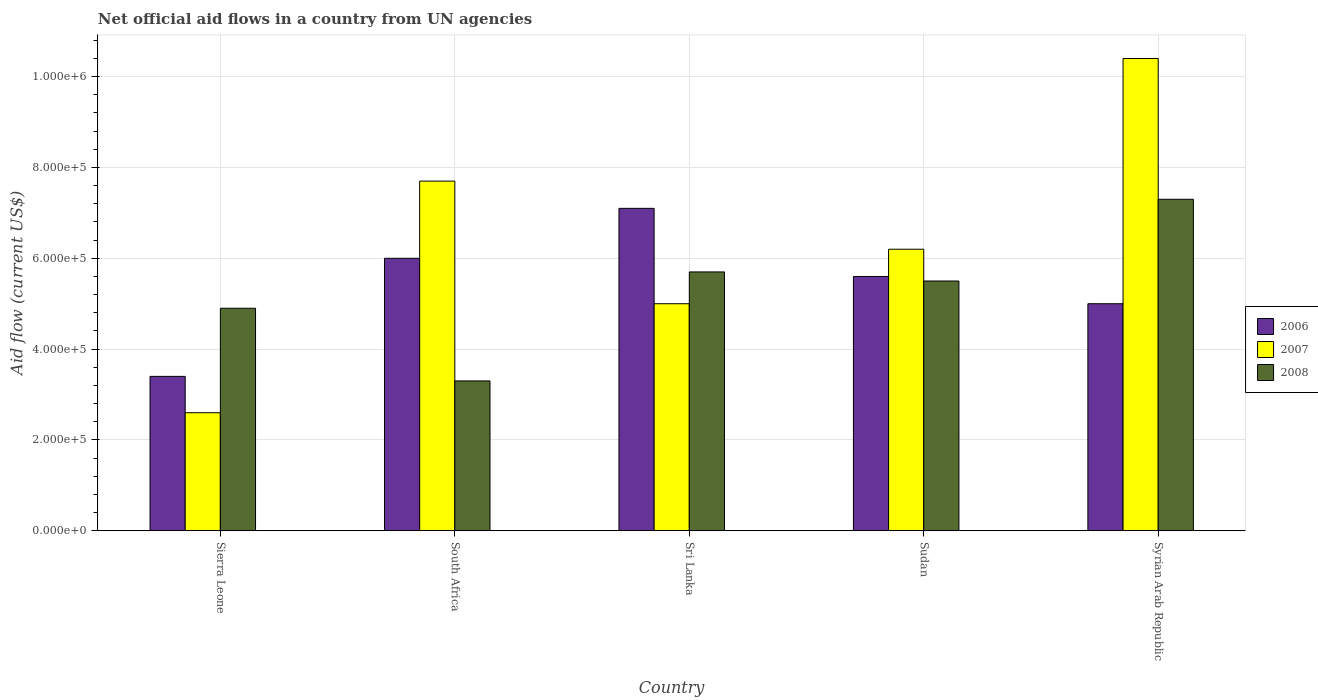How many groups of bars are there?
Keep it short and to the point. 5. How many bars are there on the 4th tick from the left?
Keep it short and to the point. 3. What is the label of the 5th group of bars from the left?
Your answer should be very brief. Syrian Arab Republic. Across all countries, what is the maximum net official aid flow in 2007?
Your answer should be very brief. 1.04e+06. Across all countries, what is the minimum net official aid flow in 2008?
Give a very brief answer. 3.30e+05. In which country was the net official aid flow in 2008 maximum?
Provide a succinct answer. Syrian Arab Republic. In which country was the net official aid flow in 2006 minimum?
Offer a terse response. Sierra Leone. What is the total net official aid flow in 2008 in the graph?
Your answer should be very brief. 2.67e+06. What is the difference between the net official aid flow in 2006 in Sri Lanka and that in Syrian Arab Republic?
Your answer should be compact. 2.10e+05. What is the difference between the net official aid flow in 2007 in Sri Lanka and the net official aid flow in 2006 in Sierra Leone?
Provide a short and direct response. 1.60e+05. What is the average net official aid flow in 2006 per country?
Provide a succinct answer. 5.42e+05. What is the difference between the net official aid flow of/in 2006 and net official aid flow of/in 2008 in Sri Lanka?
Make the answer very short. 1.40e+05. What is the ratio of the net official aid flow in 2006 in Sierra Leone to that in South Africa?
Keep it short and to the point. 0.57. What is the difference between the highest and the second highest net official aid flow in 2007?
Offer a very short reply. 4.20e+05. What is the difference between the highest and the lowest net official aid flow in 2008?
Your answer should be very brief. 4.00e+05. Is it the case that in every country, the sum of the net official aid flow in 2008 and net official aid flow in 2007 is greater than the net official aid flow in 2006?
Your answer should be very brief. Yes. How many bars are there?
Give a very brief answer. 15. Are all the bars in the graph horizontal?
Ensure brevity in your answer.  No. Are the values on the major ticks of Y-axis written in scientific E-notation?
Offer a very short reply. Yes. Does the graph contain grids?
Make the answer very short. Yes. Where does the legend appear in the graph?
Your response must be concise. Center right. How many legend labels are there?
Offer a terse response. 3. What is the title of the graph?
Give a very brief answer. Net official aid flows in a country from UN agencies. What is the label or title of the X-axis?
Your answer should be very brief. Country. What is the Aid flow (current US$) in 2006 in Sierra Leone?
Your response must be concise. 3.40e+05. What is the Aid flow (current US$) in 2007 in Sierra Leone?
Keep it short and to the point. 2.60e+05. What is the Aid flow (current US$) of 2007 in South Africa?
Provide a short and direct response. 7.70e+05. What is the Aid flow (current US$) in 2008 in South Africa?
Give a very brief answer. 3.30e+05. What is the Aid flow (current US$) of 2006 in Sri Lanka?
Keep it short and to the point. 7.10e+05. What is the Aid flow (current US$) of 2008 in Sri Lanka?
Provide a succinct answer. 5.70e+05. What is the Aid flow (current US$) in 2006 in Sudan?
Your response must be concise. 5.60e+05. What is the Aid flow (current US$) of 2007 in Sudan?
Provide a succinct answer. 6.20e+05. What is the Aid flow (current US$) in 2007 in Syrian Arab Republic?
Offer a terse response. 1.04e+06. What is the Aid flow (current US$) in 2008 in Syrian Arab Republic?
Offer a very short reply. 7.30e+05. Across all countries, what is the maximum Aid flow (current US$) in 2006?
Keep it short and to the point. 7.10e+05. Across all countries, what is the maximum Aid flow (current US$) of 2007?
Your response must be concise. 1.04e+06. Across all countries, what is the maximum Aid flow (current US$) in 2008?
Your answer should be very brief. 7.30e+05. Across all countries, what is the minimum Aid flow (current US$) of 2006?
Offer a terse response. 3.40e+05. What is the total Aid flow (current US$) in 2006 in the graph?
Provide a succinct answer. 2.71e+06. What is the total Aid flow (current US$) in 2007 in the graph?
Offer a very short reply. 3.19e+06. What is the total Aid flow (current US$) in 2008 in the graph?
Offer a very short reply. 2.67e+06. What is the difference between the Aid flow (current US$) in 2006 in Sierra Leone and that in South Africa?
Offer a very short reply. -2.60e+05. What is the difference between the Aid flow (current US$) in 2007 in Sierra Leone and that in South Africa?
Provide a short and direct response. -5.10e+05. What is the difference between the Aid flow (current US$) in 2008 in Sierra Leone and that in South Africa?
Offer a very short reply. 1.60e+05. What is the difference between the Aid flow (current US$) of 2006 in Sierra Leone and that in Sri Lanka?
Provide a short and direct response. -3.70e+05. What is the difference between the Aid flow (current US$) in 2008 in Sierra Leone and that in Sri Lanka?
Your answer should be very brief. -8.00e+04. What is the difference between the Aid flow (current US$) of 2006 in Sierra Leone and that in Sudan?
Your answer should be compact. -2.20e+05. What is the difference between the Aid flow (current US$) of 2007 in Sierra Leone and that in Sudan?
Provide a succinct answer. -3.60e+05. What is the difference between the Aid flow (current US$) of 2006 in Sierra Leone and that in Syrian Arab Republic?
Keep it short and to the point. -1.60e+05. What is the difference between the Aid flow (current US$) of 2007 in Sierra Leone and that in Syrian Arab Republic?
Ensure brevity in your answer.  -7.80e+05. What is the difference between the Aid flow (current US$) of 2006 in South Africa and that in Sri Lanka?
Make the answer very short. -1.10e+05. What is the difference between the Aid flow (current US$) in 2007 in South Africa and that in Sri Lanka?
Offer a very short reply. 2.70e+05. What is the difference between the Aid flow (current US$) in 2006 in South Africa and that in Sudan?
Provide a short and direct response. 4.00e+04. What is the difference between the Aid flow (current US$) in 2008 in South Africa and that in Sudan?
Provide a short and direct response. -2.20e+05. What is the difference between the Aid flow (current US$) in 2007 in South Africa and that in Syrian Arab Republic?
Your response must be concise. -2.70e+05. What is the difference between the Aid flow (current US$) in 2008 in South Africa and that in Syrian Arab Republic?
Make the answer very short. -4.00e+05. What is the difference between the Aid flow (current US$) of 2006 in Sri Lanka and that in Sudan?
Your response must be concise. 1.50e+05. What is the difference between the Aid flow (current US$) of 2007 in Sri Lanka and that in Sudan?
Your answer should be compact. -1.20e+05. What is the difference between the Aid flow (current US$) of 2006 in Sri Lanka and that in Syrian Arab Republic?
Make the answer very short. 2.10e+05. What is the difference between the Aid flow (current US$) of 2007 in Sri Lanka and that in Syrian Arab Republic?
Provide a succinct answer. -5.40e+05. What is the difference between the Aid flow (current US$) in 2006 in Sudan and that in Syrian Arab Republic?
Make the answer very short. 6.00e+04. What is the difference between the Aid flow (current US$) in 2007 in Sudan and that in Syrian Arab Republic?
Your answer should be very brief. -4.20e+05. What is the difference between the Aid flow (current US$) in 2008 in Sudan and that in Syrian Arab Republic?
Ensure brevity in your answer.  -1.80e+05. What is the difference between the Aid flow (current US$) of 2006 in Sierra Leone and the Aid flow (current US$) of 2007 in South Africa?
Keep it short and to the point. -4.30e+05. What is the difference between the Aid flow (current US$) of 2007 in Sierra Leone and the Aid flow (current US$) of 2008 in South Africa?
Keep it short and to the point. -7.00e+04. What is the difference between the Aid flow (current US$) of 2006 in Sierra Leone and the Aid flow (current US$) of 2007 in Sri Lanka?
Offer a terse response. -1.60e+05. What is the difference between the Aid flow (current US$) in 2007 in Sierra Leone and the Aid flow (current US$) in 2008 in Sri Lanka?
Provide a succinct answer. -3.10e+05. What is the difference between the Aid flow (current US$) in 2006 in Sierra Leone and the Aid flow (current US$) in 2007 in Sudan?
Give a very brief answer. -2.80e+05. What is the difference between the Aid flow (current US$) of 2006 in Sierra Leone and the Aid flow (current US$) of 2008 in Sudan?
Provide a succinct answer. -2.10e+05. What is the difference between the Aid flow (current US$) in 2007 in Sierra Leone and the Aid flow (current US$) in 2008 in Sudan?
Make the answer very short. -2.90e+05. What is the difference between the Aid flow (current US$) of 2006 in Sierra Leone and the Aid flow (current US$) of 2007 in Syrian Arab Republic?
Offer a terse response. -7.00e+05. What is the difference between the Aid flow (current US$) of 2006 in Sierra Leone and the Aid flow (current US$) of 2008 in Syrian Arab Republic?
Your response must be concise. -3.90e+05. What is the difference between the Aid flow (current US$) in 2007 in Sierra Leone and the Aid flow (current US$) in 2008 in Syrian Arab Republic?
Give a very brief answer. -4.70e+05. What is the difference between the Aid flow (current US$) in 2006 in South Africa and the Aid flow (current US$) in 2008 in Sri Lanka?
Your response must be concise. 3.00e+04. What is the difference between the Aid flow (current US$) of 2006 in South Africa and the Aid flow (current US$) of 2008 in Sudan?
Offer a terse response. 5.00e+04. What is the difference between the Aid flow (current US$) of 2006 in South Africa and the Aid flow (current US$) of 2007 in Syrian Arab Republic?
Give a very brief answer. -4.40e+05. What is the difference between the Aid flow (current US$) of 2006 in South Africa and the Aid flow (current US$) of 2008 in Syrian Arab Republic?
Ensure brevity in your answer.  -1.30e+05. What is the difference between the Aid flow (current US$) of 2006 in Sri Lanka and the Aid flow (current US$) of 2007 in Sudan?
Keep it short and to the point. 9.00e+04. What is the difference between the Aid flow (current US$) of 2006 in Sri Lanka and the Aid flow (current US$) of 2008 in Sudan?
Keep it short and to the point. 1.60e+05. What is the difference between the Aid flow (current US$) in 2006 in Sri Lanka and the Aid flow (current US$) in 2007 in Syrian Arab Republic?
Your answer should be very brief. -3.30e+05. What is the difference between the Aid flow (current US$) in 2006 in Sri Lanka and the Aid flow (current US$) in 2008 in Syrian Arab Republic?
Your answer should be very brief. -2.00e+04. What is the difference between the Aid flow (current US$) in 2007 in Sri Lanka and the Aid flow (current US$) in 2008 in Syrian Arab Republic?
Your response must be concise. -2.30e+05. What is the difference between the Aid flow (current US$) in 2006 in Sudan and the Aid flow (current US$) in 2007 in Syrian Arab Republic?
Make the answer very short. -4.80e+05. What is the difference between the Aid flow (current US$) in 2007 in Sudan and the Aid flow (current US$) in 2008 in Syrian Arab Republic?
Provide a succinct answer. -1.10e+05. What is the average Aid flow (current US$) in 2006 per country?
Your answer should be very brief. 5.42e+05. What is the average Aid flow (current US$) of 2007 per country?
Offer a very short reply. 6.38e+05. What is the average Aid flow (current US$) in 2008 per country?
Provide a succinct answer. 5.34e+05. What is the difference between the Aid flow (current US$) in 2006 and Aid flow (current US$) in 2007 in Sierra Leone?
Your answer should be compact. 8.00e+04. What is the difference between the Aid flow (current US$) of 2007 and Aid flow (current US$) of 2008 in Sierra Leone?
Offer a terse response. -2.30e+05. What is the difference between the Aid flow (current US$) in 2006 and Aid flow (current US$) in 2008 in South Africa?
Make the answer very short. 2.70e+05. What is the difference between the Aid flow (current US$) of 2006 and Aid flow (current US$) of 2007 in Sri Lanka?
Make the answer very short. 2.10e+05. What is the difference between the Aid flow (current US$) of 2006 and Aid flow (current US$) of 2008 in Sri Lanka?
Your response must be concise. 1.40e+05. What is the difference between the Aid flow (current US$) in 2007 and Aid flow (current US$) in 2008 in Sudan?
Your answer should be compact. 7.00e+04. What is the difference between the Aid flow (current US$) of 2006 and Aid flow (current US$) of 2007 in Syrian Arab Republic?
Provide a succinct answer. -5.40e+05. What is the ratio of the Aid flow (current US$) in 2006 in Sierra Leone to that in South Africa?
Provide a succinct answer. 0.57. What is the ratio of the Aid flow (current US$) in 2007 in Sierra Leone to that in South Africa?
Provide a short and direct response. 0.34. What is the ratio of the Aid flow (current US$) of 2008 in Sierra Leone to that in South Africa?
Make the answer very short. 1.48. What is the ratio of the Aid flow (current US$) in 2006 in Sierra Leone to that in Sri Lanka?
Ensure brevity in your answer.  0.48. What is the ratio of the Aid flow (current US$) in 2007 in Sierra Leone to that in Sri Lanka?
Offer a terse response. 0.52. What is the ratio of the Aid flow (current US$) in 2008 in Sierra Leone to that in Sri Lanka?
Your answer should be very brief. 0.86. What is the ratio of the Aid flow (current US$) of 2006 in Sierra Leone to that in Sudan?
Ensure brevity in your answer.  0.61. What is the ratio of the Aid flow (current US$) in 2007 in Sierra Leone to that in Sudan?
Provide a short and direct response. 0.42. What is the ratio of the Aid flow (current US$) of 2008 in Sierra Leone to that in Sudan?
Offer a terse response. 0.89. What is the ratio of the Aid flow (current US$) in 2006 in Sierra Leone to that in Syrian Arab Republic?
Provide a short and direct response. 0.68. What is the ratio of the Aid flow (current US$) in 2007 in Sierra Leone to that in Syrian Arab Republic?
Ensure brevity in your answer.  0.25. What is the ratio of the Aid flow (current US$) in 2008 in Sierra Leone to that in Syrian Arab Republic?
Provide a short and direct response. 0.67. What is the ratio of the Aid flow (current US$) in 2006 in South Africa to that in Sri Lanka?
Your answer should be compact. 0.85. What is the ratio of the Aid flow (current US$) in 2007 in South Africa to that in Sri Lanka?
Offer a terse response. 1.54. What is the ratio of the Aid flow (current US$) in 2008 in South Africa to that in Sri Lanka?
Keep it short and to the point. 0.58. What is the ratio of the Aid flow (current US$) in 2006 in South Africa to that in Sudan?
Make the answer very short. 1.07. What is the ratio of the Aid flow (current US$) in 2007 in South Africa to that in Sudan?
Your answer should be compact. 1.24. What is the ratio of the Aid flow (current US$) of 2008 in South Africa to that in Sudan?
Make the answer very short. 0.6. What is the ratio of the Aid flow (current US$) in 2007 in South Africa to that in Syrian Arab Republic?
Keep it short and to the point. 0.74. What is the ratio of the Aid flow (current US$) of 2008 in South Africa to that in Syrian Arab Republic?
Your answer should be compact. 0.45. What is the ratio of the Aid flow (current US$) in 2006 in Sri Lanka to that in Sudan?
Offer a terse response. 1.27. What is the ratio of the Aid flow (current US$) of 2007 in Sri Lanka to that in Sudan?
Your answer should be compact. 0.81. What is the ratio of the Aid flow (current US$) of 2008 in Sri Lanka to that in Sudan?
Offer a very short reply. 1.04. What is the ratio of the Aid flow (current US$) of 2006 in Sri Lanka to that in Syrian Arab Republic?
Provide a succinct answer. 1.42. What is the ratio of the Aid flow (current US$) of 2007 in Sri Lanka to that in Syrian Arab Republic?
Your answer should be compact. 0.48. What is the ratio of the Aid flow (current US$) of 2008 in Sri Lanka to that in Syrian Arab Republic?
Your answer should be very brief. 0.78. What is the ratio of the Aid flow (current US$) in 2006 in Sudan to that in Syrian Arab Republic?
Offer a very short reply. 1.12. What is the ratio of the Aid flow (current US$) in 2007 in Sudan to that in Syrian Arab Republic?
Offer a terse response. 0.6. What is the ratio of the Aid flow (current US$) in 2008 in Sudan to that in Syrian Arab Republic?
Keep it short and to the point. 0.75. What is the difference between the highest and the second highest Aid flow (current US$) in 2007?
Offer a terse response. 2.70e+05. What is the difference between the highest and the lowest Aid flow (current US$) in 2006?
Ensure brevity in your answer.  3.70e+05. What is the difference between the highest and the lowest Aid flow (current US$) in 2007?
Your response must be concise. 7.80e+05. 